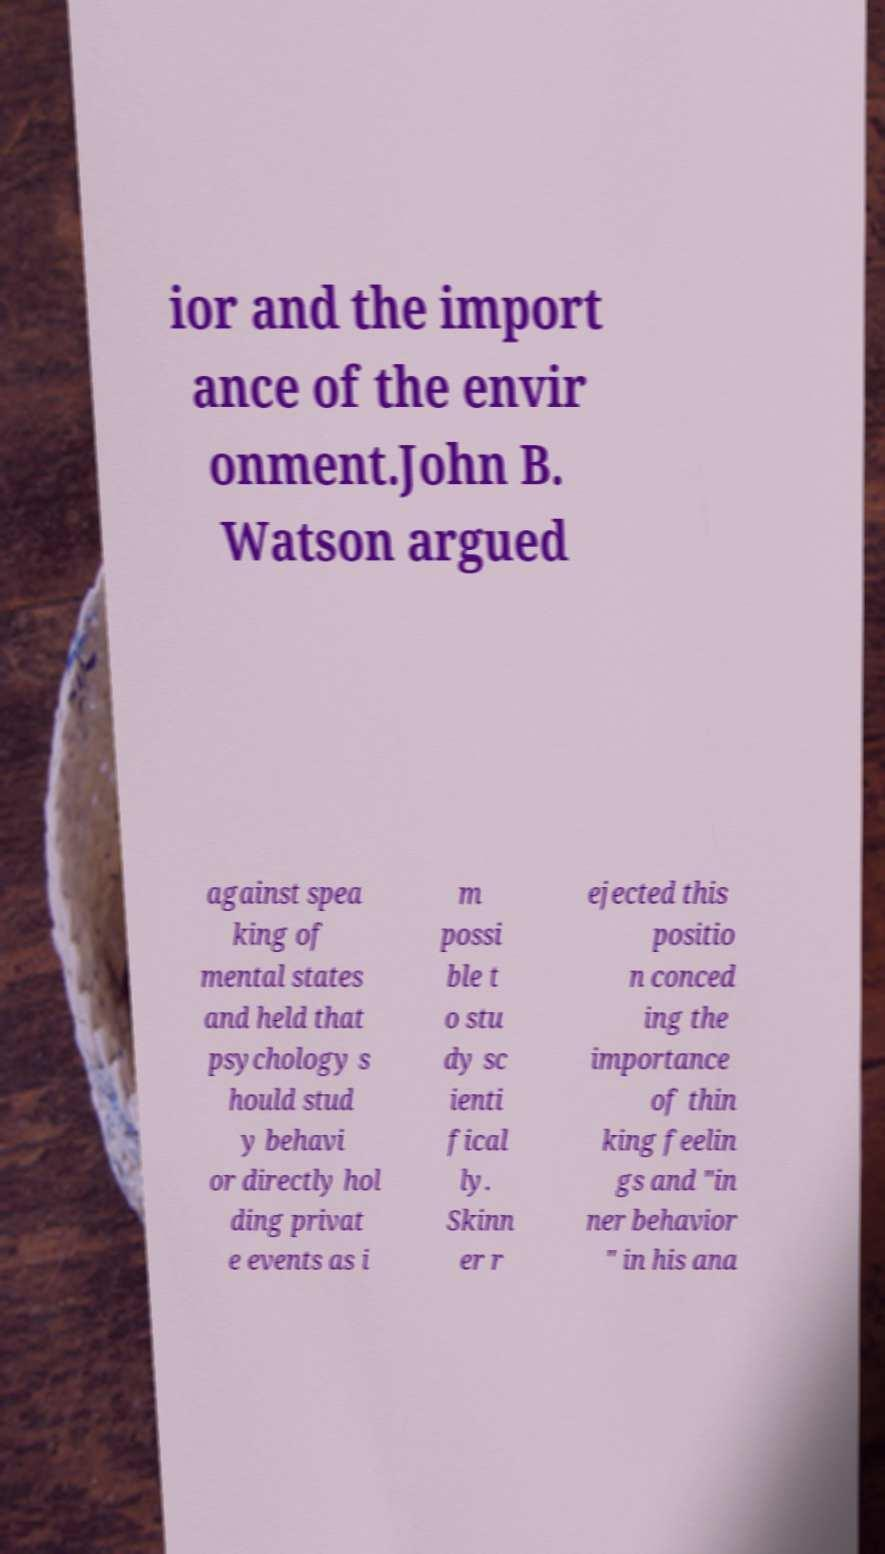Please read and relay the text visible in this image. What does it say? ior and the import ance of the envir onment.John B. Watson argued against spea king of mental states and held that psychology s hould stud y behavi or directly hol ding privat e events as i m possi ble t o stu dy sc ienti fical ly. Skinn er r ejected this positio n conced ing the importance of thin king feelin gs and "in ner behavior " in his ana 